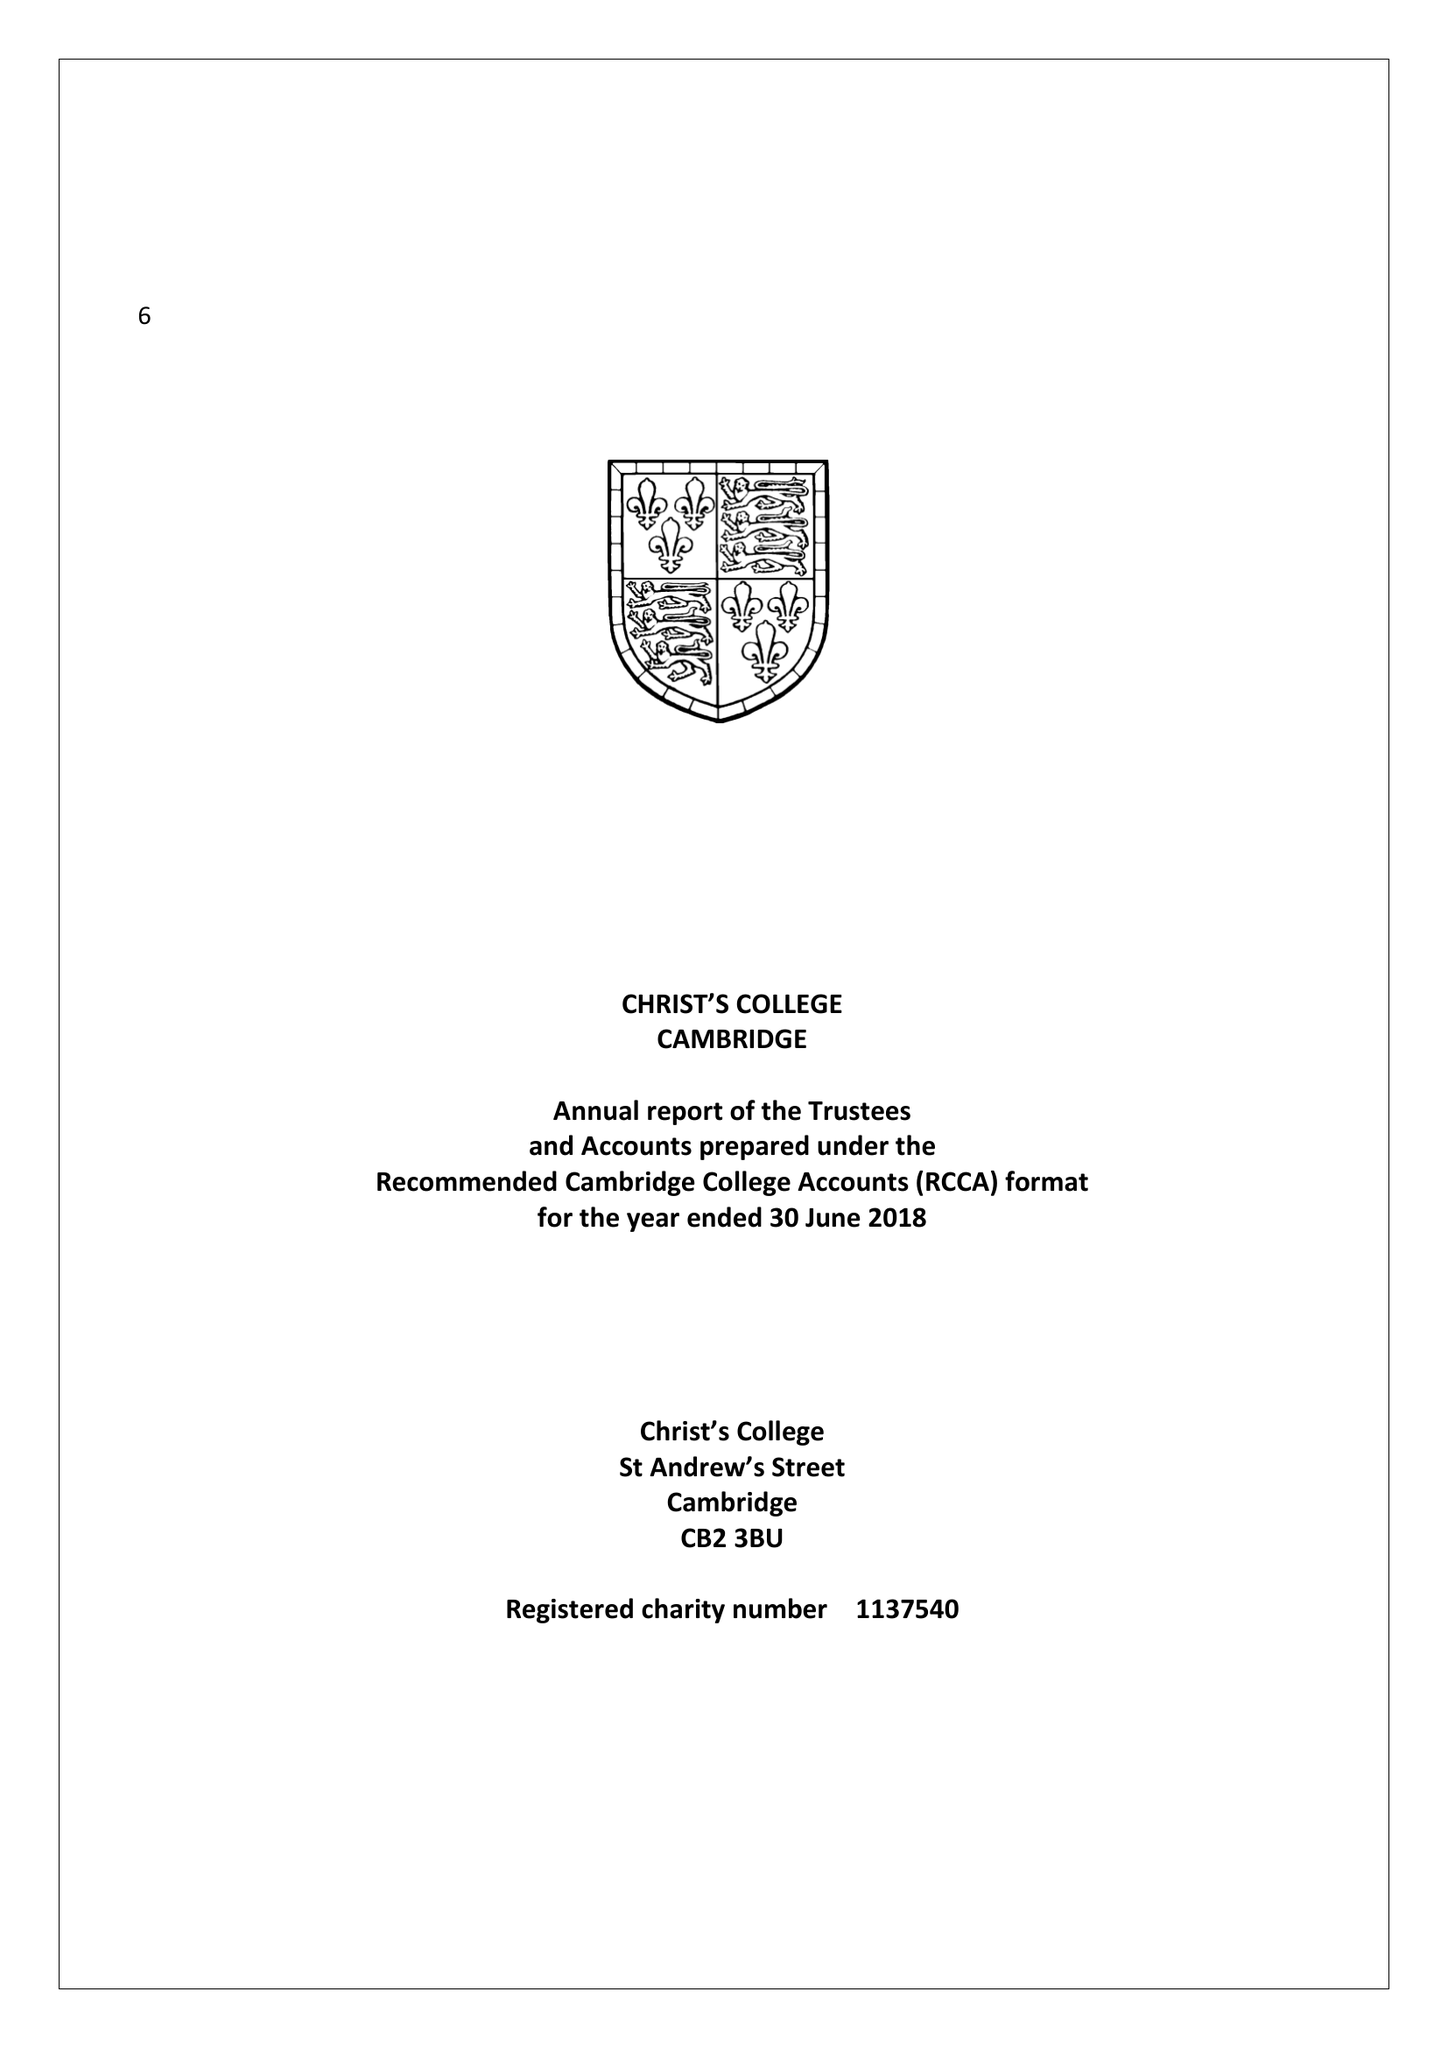What is the value for the income_annually_in_british_pounds?
Answer the question using a single word or phrase. 12048548.00 